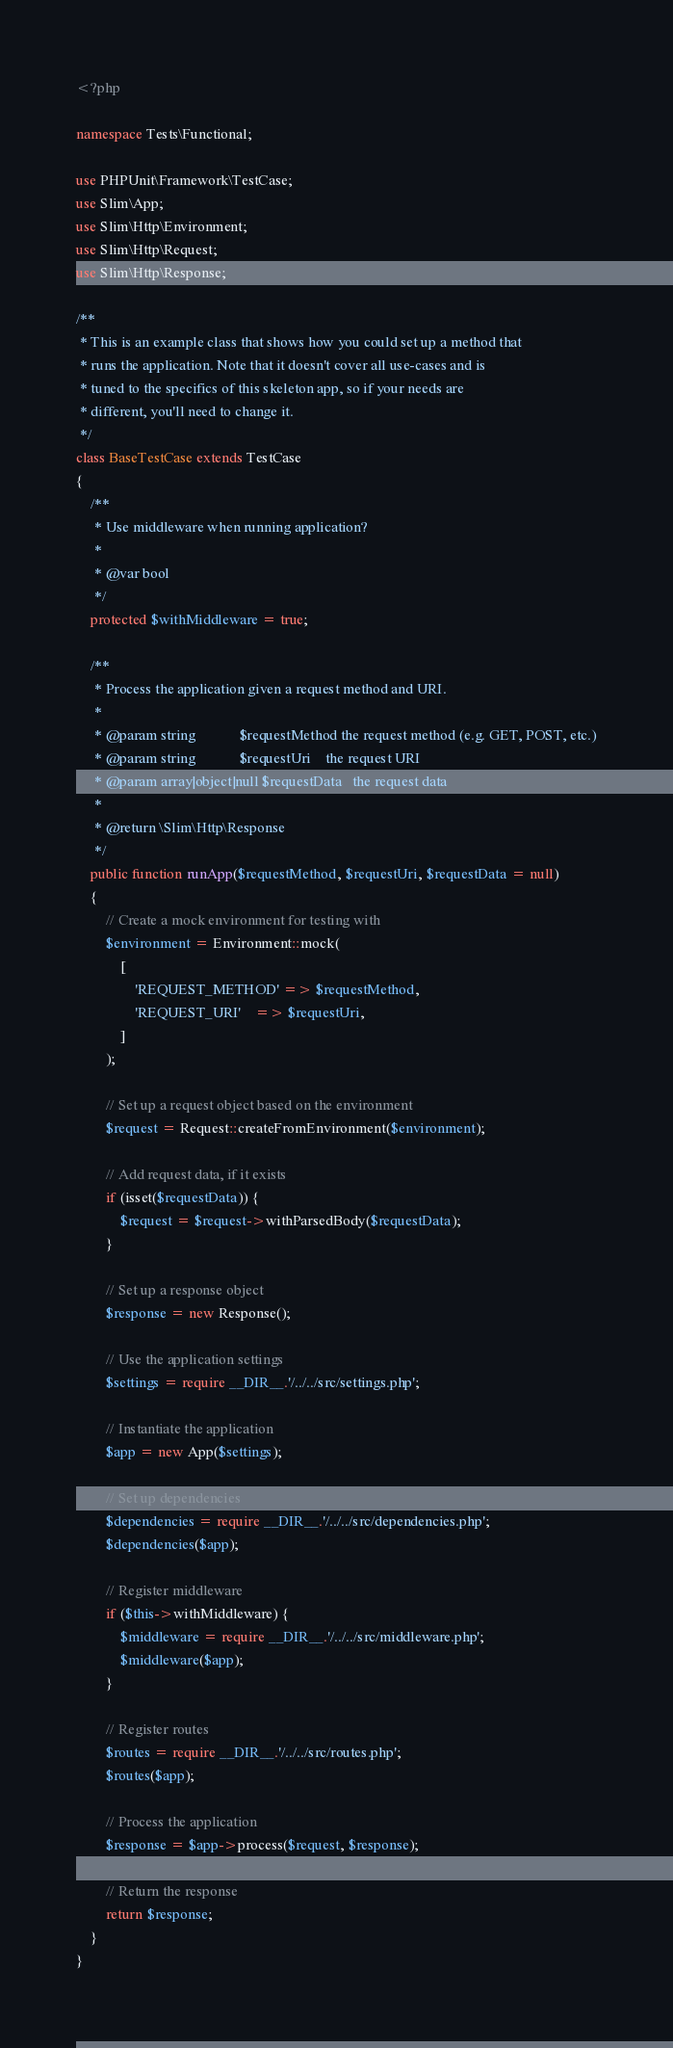<code> <loc_0><loc_0><loc_500><loc_500><_PHP_><?php

namespace Tests\Functional;

use PHPUnit\Framework\TestCase;
use Slim\App;
use Slim\Http\Environment;
use Slim\Http\Request;
use Slim\Http\Response;

/**
 * This is an example class that shows how you could set up a method that
 * runs the application. Note that it doesn't cover all use-cases and is
 * tuned to the specifics of this skeleton app, so if your needs are
 * different, you'll need to change it.
 */
class BaseTestCase extends TestCase
{
    /**
     * Use middleware when running application?
     *
     * @var bool
     */
    protected $withMiddleware = true;

    /**
     * Process the application given a request method and URI.
     *
     * @param string            $requestMethod the request method (e.g. GET, POST, etc.)
     * @param string            $requestUri    the request URI
     * @param array|object|null $requestData   the request data
     *
     * @return \Slim\Http\Response
     */
    public function runApp($requestMethod, $requestUri, $requestData = null)
    {
        // Create a mock environment for testing with
        $environment = Environment::mock(
            [
                'REQUEST_METHOD' => $requestMethod,
                'REQUEST_URI'    => $requestUri,
            ]
        );

        // Set up a request object based on the environment
        $request = Request::createFromEnvironment($environment);

        // Add request data, if it exists
        if (isset($requestData)) {
            $request = $request->withParsedBody($requestData);
        }

        // Set up a response object
        $response = new Response();

        // Use the application settings
        $settings = require __DIR__.'/../../src/settings.php';

        // Instantiate the application
        $app = new App($settings);

        // Set up dependencies
        $dependencies = require __DIR__.'/../../src/dependencies.php';
        $dependencies($app);

        // Register middleware
        if ($this->withMiddleware) {
            $middleware = require __DIR__.'/../../src/middleware.php';
            $middleware($app);
        }

        // Register routes
        $routes = require __DIR__.'/../../src/routes.php';
        $routes($app);

        // Process the application
        $response = $app->process($request, $response);

        // Return the response
        return $response;
    }
}
</code> 